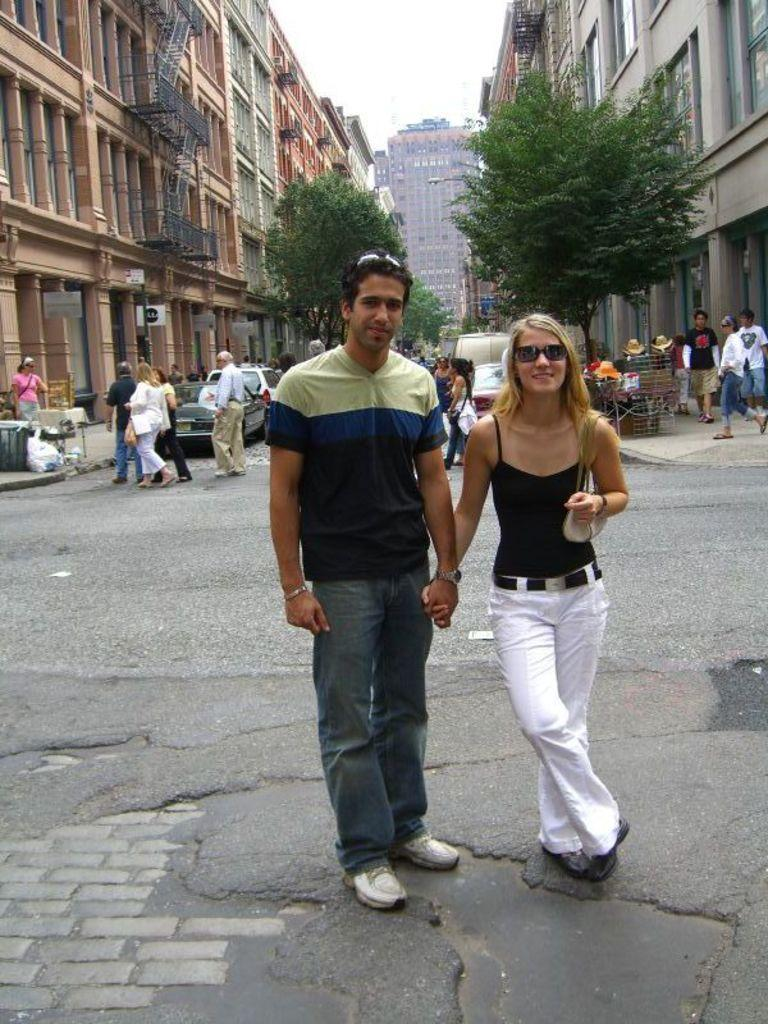Who or what can be seen in the image? There are people in the image. What else is present in the image besides people? There are vehicles on the road in the image. What can be seen in the background of the image? There are trees, buildings, and the sky visible in the background of the image. What type of grain is being transported by the people in the image? There is no grain present in the image, nor is there any indication that the people are transporting anything. 